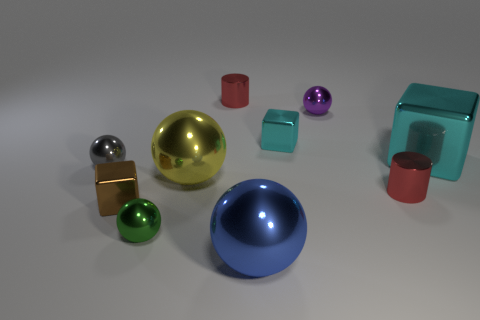Subtract all large blue metallic balls. How many balls are left? 4 Subtract all yellow balls. How many cyan cubes are left? 2 Subtract all blue spheres. How many spheres are left? 4 Subtract all cyan spheres. Subtract all cyan cubes. How many spheres are left? 5 Add 6 small cyan metallic blocks. How many small cyan metallic blocks exist? 7 Subtract 0 blue cylinders. How many objects are left? 10 Subtract all cubes. How many objects are left? 7 Subtract all tiny brown matte spheres. Subtract all blue objects. How many objects are left? 9 Add 4 small red things. How many small red things are left? 6 